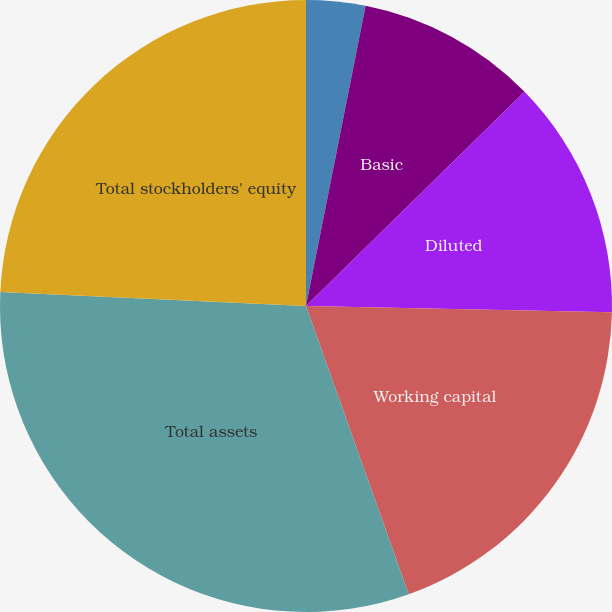Convert chart. <chart><loc_0><loc_0><loc_500><loc_500><pie_chart><fcel>Basic net (loss) income per<fcel>Diluted net (loss) income per<fcel>Basic<fcel>Diluted<fcel>Working capital<fcel>Total assets<fcel>Total stockholders' equity<nl><fcel>3.12%<fcel>0.0%<fcel>9.54%<fcel>12.66%<fcel>19.23%<fcel>31.18%<fcel>24.27%<nl></chart> 